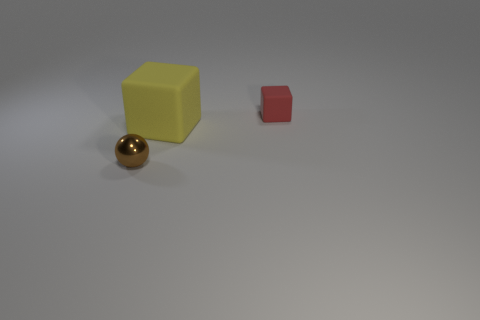Add 3 yellow objects. How many objects exist? 6 Subtract 2 blocks. How many blocks are left? 0 Subtract all brown blocks. Subtract all cyan cylinders. How many blocks are left? 2 Subtract all green balls. How many red cubes are left? 1 Subtract all large gray metallic cylinders. Subtract all yellow cubes. How many objects are left? 2 Add 1 brown things. How many brown things are left? 2 Add 2 small spheres. How many small spheres exist? 3 Subtract 0 blue cubes. How many objects are left? 3 Subtract all blocks. How many objects are left? 1 